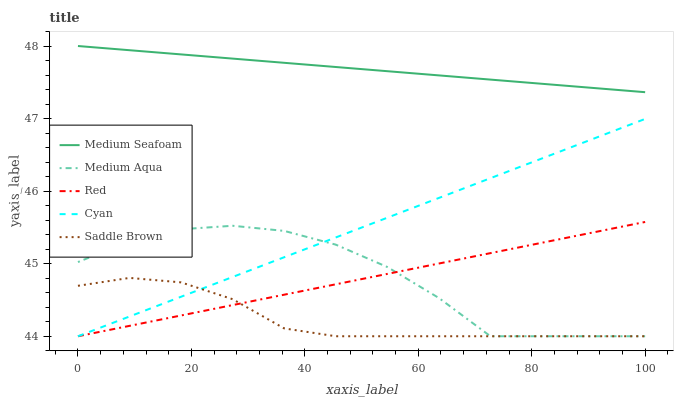Does Saddle Brown have the minimum area under the curve?
Answer yes or no. Yes. Does Medium Seafoam have the maximum area under the curve?
Answer yes or no. Yes. Does Medium Aqua have the minimum area under the curve?
Answer yes or no. No. Does Medium Aqua have the maximum area under the curve?
Answer yes or no. No. Is Red the smoothest?
Answer yes or no. Yes. Is Medium Aqua the roughest?
Answer yes or no. Yes. Is Medium Seafoam the smoothest?
Answer yes or no. No. Is Medium Seafoam the roughest?
Answer yes or no. No. Does Cyan have the lowest value?
Answer yes or no. Yes. Does Medium Seafoam have the lowest value?
Answer yes or no. No. Does Medium Seafoam have the highest value?
Answer yes or no. Yes. Does Medium Aqua have the highest value?
Answer yes or no. No. Is Medium Aqua less than Medium Seafoam?
Answer yes or no. Yes. Is Medium Seafoam greater than Medium Aqua?
Answer yes or no. Yes. Does Saddle Brown intersect Cyan?
Answer yes or no. Yes. Is Saddle Brown less than Cyan?
Answer yes or no. No. Is Saddle Brown greater than Cyan?
Answer yes or no. No. Does Medium Aqua intersect Medium Seafoam?
Answer yes or no. No. 